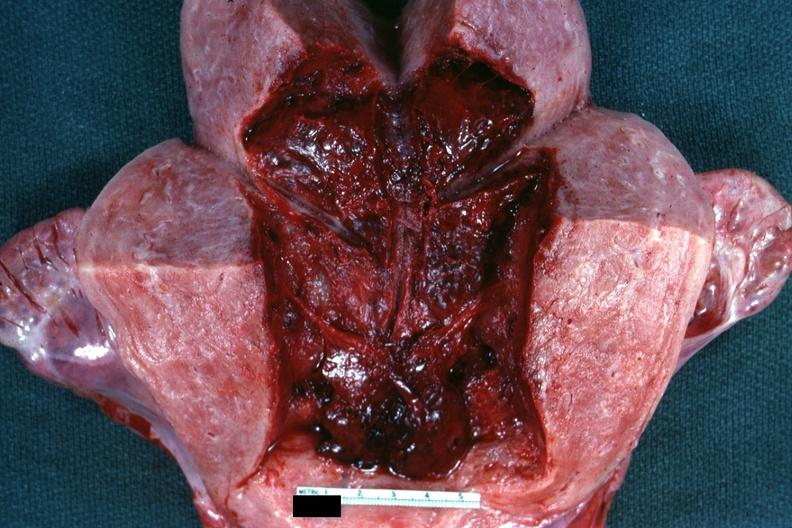s female reproductive present?
Answer the question using a single word or phrase. Yes 